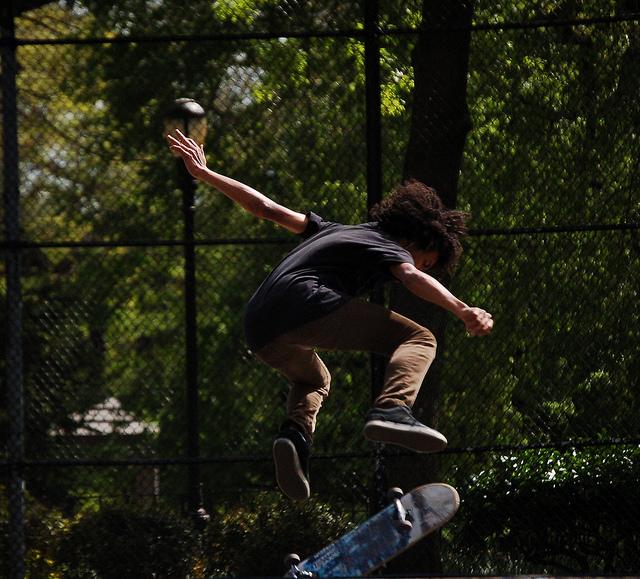Is the athlete wearing any protective equipment?
Concise answer only. No. What is that white disk?
Keep it brief. Skateboard. What is the boy wearing?
Concise answer only. Black shirt and brown pants. What is the boy doing?
Write a very short answer. Skateboarding. 